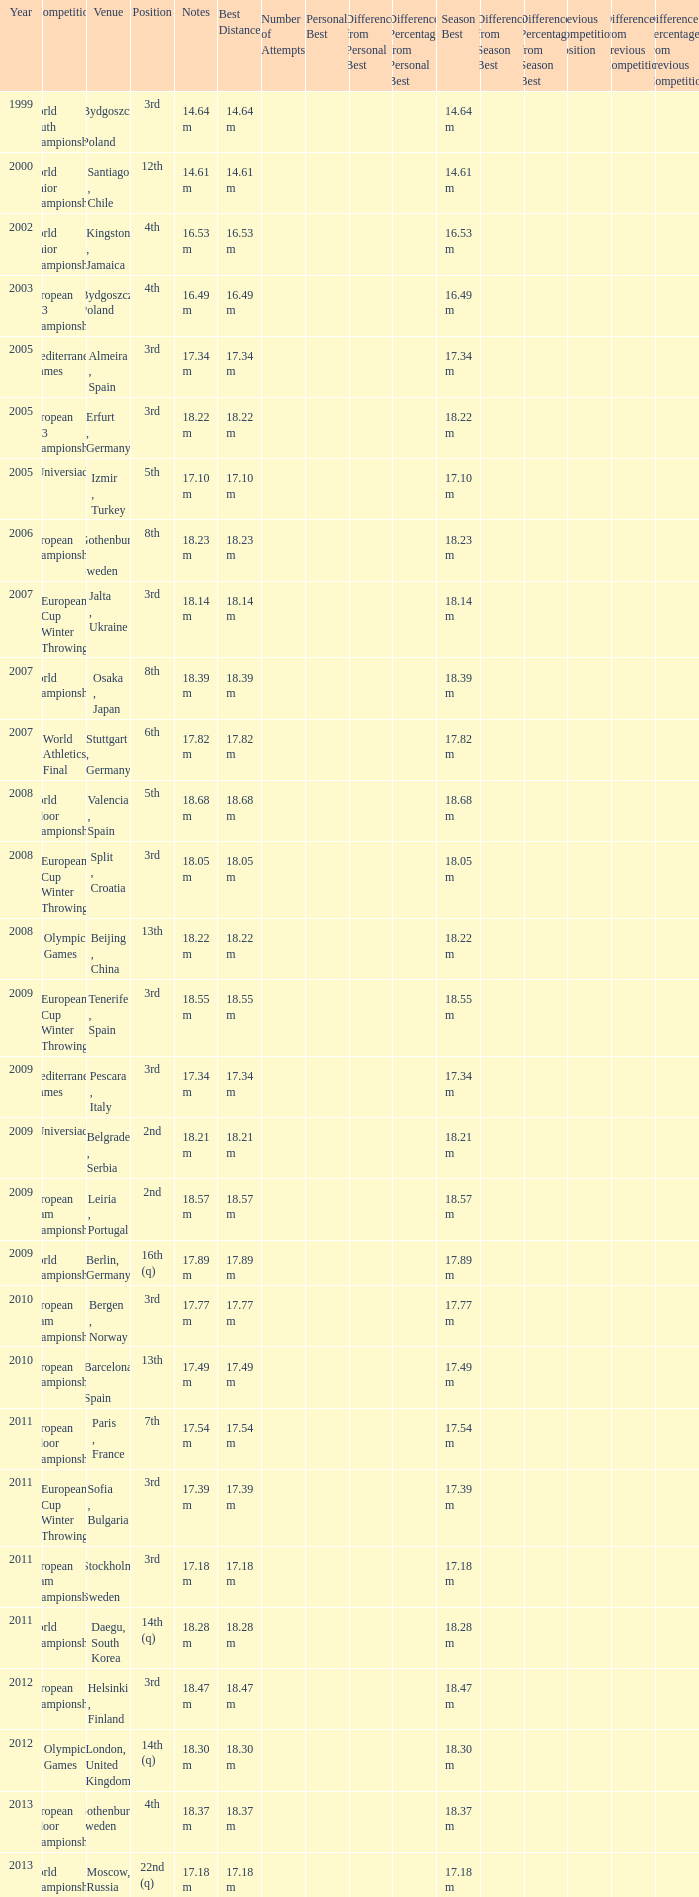Where were the Mediterranean games after 2005? Pescara , Italy. 